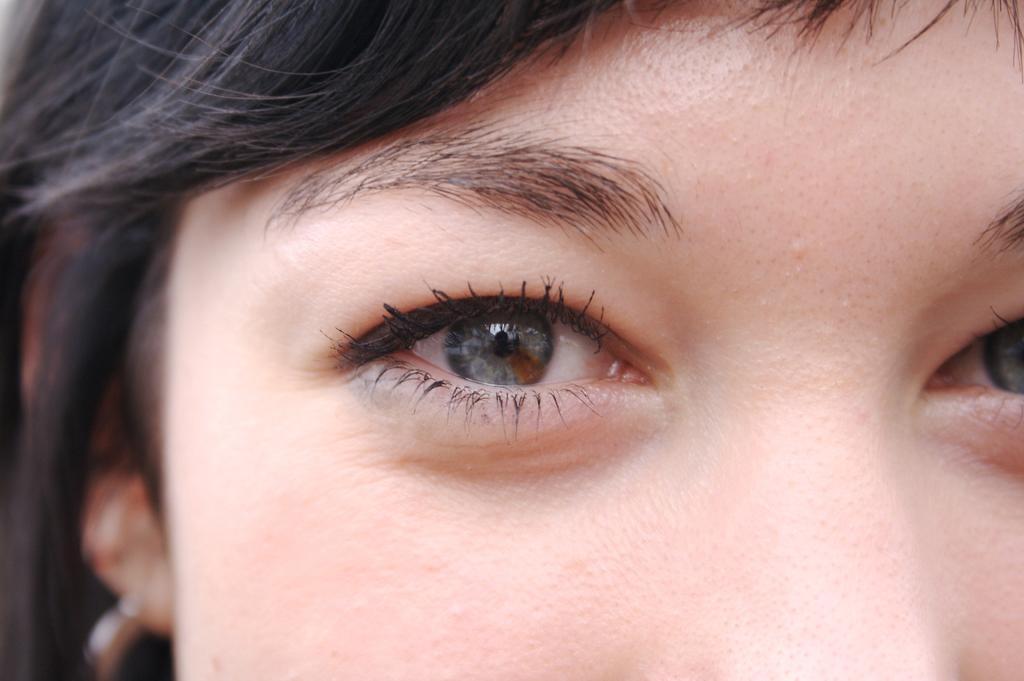Can you describe this image briefly? In this image there is a lady. 